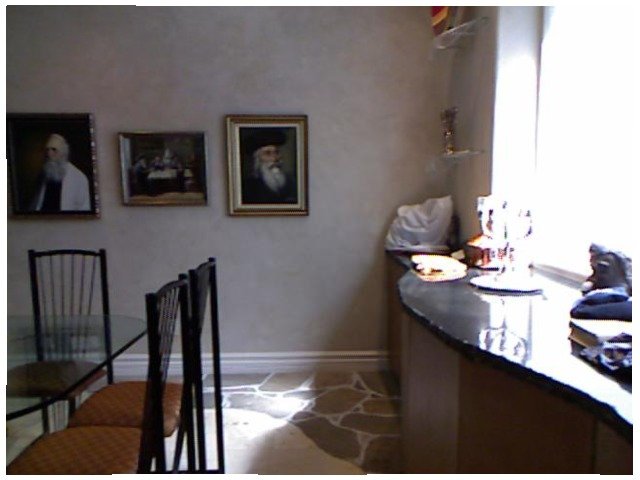<image>
Can you confirm if the chair is behind the table? Yes. From this viewpoint, the chair is positioned behind the table, with the table partially or fully occluding the chair. Where is the wall in relation to the photo frame? Is it behind the photo frame? Yes. From this viewpoint, the wall is positioned behind the photo frame, with the photo frame partially or fully occluding the wall. Is there a picture behind the wall? No. The picture is not behind the wall. From this viewpoint, the picture appears to be positioned elsewhere in the scene. 